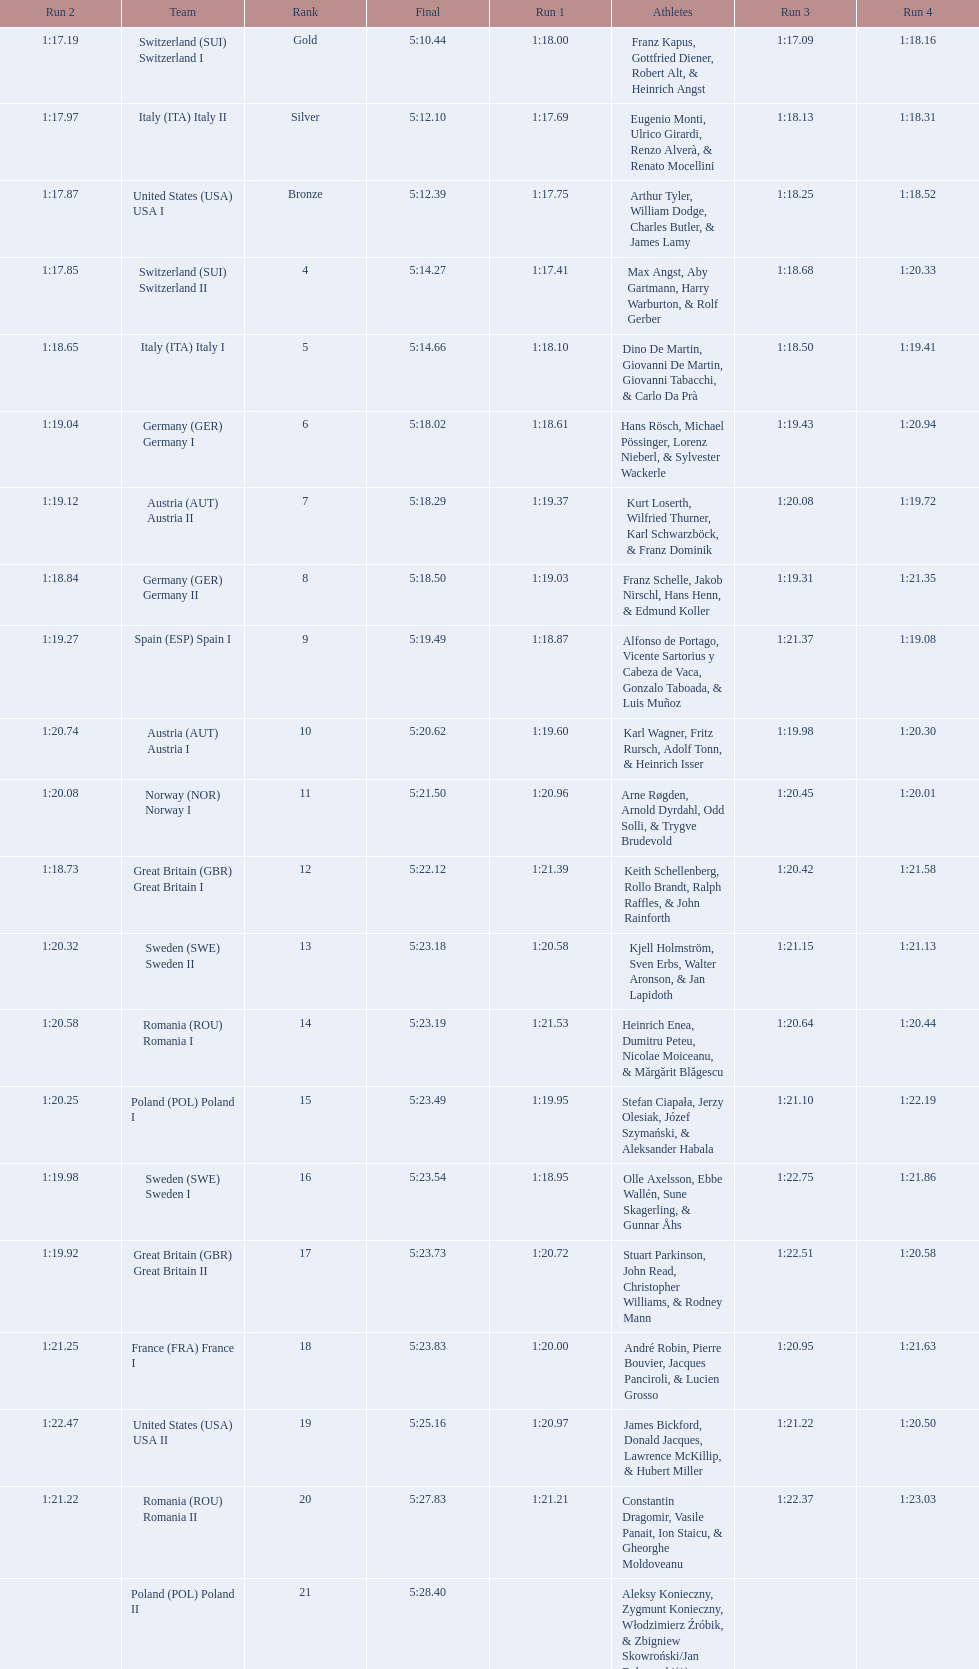What team came in second to last place? Romania. Can you parse all the data within this table? {'header': ['Run 2', 'Team', 'Rank', 'Final', 'Run 1', 'Athletes', 'Run 3', 'Run 4'], 'rows': [['1:17.19', 'Switzerland\xa0(SUI) Switzerland I', 'Gold', '5:10.44', '1:18.00', 'Franz Kapus, Gottfried Diener, Robert Alt, & Heinrich Angst', '1:17.09', '1:18.16'], ['1:17.97', 'Italy\xa0(ITA) Italy II', 'Silver', '5:12.10', '1:17.69', 'Eugenio Monti, Ulrico Girardi, Renzo Alverà, & Renato Mocellini', '1:18.13', '1:18.31'], ['1:17.87', 'United States\xa0(USA) USA I', 'Bronze', '5:12.39', '1:17.75', 'Arthur Tyler, William Dodge, Charles Butler, & James Lamy', '1:18.25', '1:18.52'], ['1:17.85', 'Switzerland\xa0(SUI) Switzerland II', '4', '5:14.27', '1:17.41', 'Max Angst, Aby Gartmann, Harry Warburton, & Rolf Gerber', '1:18.68', '1:20.33'], ['1:18.65', 'Italy\xa0(ITA) Italy I', '5', '5:14.66', '1:18.10', 'Dino De Martin, Giovanni De Martin, Giovanni Tabacchi, & Carlo Da Prà', '1:18.50', '1:19.41'], ['1:19.04', 'Germany\xa0(GER) Germany I', '6', '5:18.02', '1:18.61', 'Hans Rösch, Michael Pössinger, Lorenz Nieberl, & Sylvester Wackerle', '1:19.43', '1:20.94'], ['1:19.12', 'Austria\xa0(AUT) Austria II', '7', '5:18.29', '1:19.37', 'Kurt Loserth, Wilfried Thurner, Karl Schwarzböck, & Franz Dominik', '1:20.08', '1:19.72'], ['1:18.84', 'Germany\xa0(GER) Germany II', '8', '5:18.50', '1:19.03', 'Franz Schelle, Jakob Nirschl, Hans Henn, & Edmund Koller', '1:19.31', '1:21.35'], ['1:19.27', 'Spain\xa0(ESP) Spain I', '9', '5:19.49', '1:18.87', 'Alfonso de Portago, Vicente Sartorius y Cabeza de Vaca, Gonzalo Taboada, & Luis Muñoz', '1:21.37', '1:19.08'], ['1:20.74', 'Austria\xa0(AUT) Austria I', '10', '5:20.62', '1:19.60', 'Karl Wagner, Fritz Rursch, Adolf Tonn, & Heinrich Isser', '1:19.98', '1:20.30'], ['1:20.08', 'Norway\xa0(NOR) Norway I', '11', '5:21.50', '1:20.96', 'Arne Røgden, Arnold Dyrdahl, Odd Solli, & Trygve Brudevold', '1:20.45', '1:20.01'], ['1:18.73', 'Great Britain\xa0(GBR) Great Britain I', '12', '5:22.12', '1:21.39', 'Keith Schellenberg, Rollo Brandt, Ralph Raffles, & John Rainforth', '1:20.42', '1:21.58'], ['1:20.32', 'Sweden\xa0(SWE) Sweden II', '13', '5:23.18', '1:20.58', 'Kjell Holmström, Sven Erbs, Walter Aronson, & Jan Lapidoth', '1:21.15', '1:21.13'], ['1:20.58', 'Romania\xa0(ROU) Romania I', '14', '5:23.19', '1:21.53', 'Heinrich Enea, Dumitru Peteu, Nicolae Moiceanu, & Mărgărit Blăgescu', '1:20.64', '1:20.44'], ['1:20.25', 'Poland\xa0(POL) Poland I', '15', '5:23.49', '1:19.95', 'Stefan Ciapała, Jerzy Olesiak, Józef Szymański, & Aleksander Habala', '1:21.10', '1:22.19'], ['1:19.98', 'Sweden\xa0(SWE) Sweden I', '16', '5:23.54', '1:18.95', 'Olle Axelsson, Ebbe Wallén, Sune Skagerling, & Gunnar Åhs', '1:22.75', '1:21.86'], ['1:19.92', 'Great Britain\xa0(GBR) Great Britain II', '17', '5:23.73', '1:20.72', 'Stuart Parkinson, John Read, Christopher Williams, & Rodney Mann', '1:22.51', '1:20.58'], ['1:21.25', 'France\xa0(FRA) France I', '18', '5:23.83', '1:20.00', 'André Robin, Pierre Bouvier, Jacques Panciroli, & Lucien Grosso', '1:20.95', '1:21.63'], ['1:22.47', 'United States\xa0(USA) USA II', '19', '5:25.16', '1:20.97', 'James Bickford, Donald Jacques, Lawrence McKillip, & Hubert Miller', '1:21.22', '1:20.50'], ['1:21.22', 'Romania\xa0(ROU) Romania II', '20', '5:27.83', '1:21.21', 'Constantin Dragomir, Vasile Panait, Ion Staicu, & Gheorghe Moldoveanu', '1:22.37', '1:23.03'], ['', 'Poland\xa0(POL) Poland II', '21', '5:28.40', '', 'Aleksy Konieczny, Zygmunt Konieczny, Włodzimierz Źróbik, & Zbigniew Skowroński/Jan Dąbrowski(*)', '', '']]} 